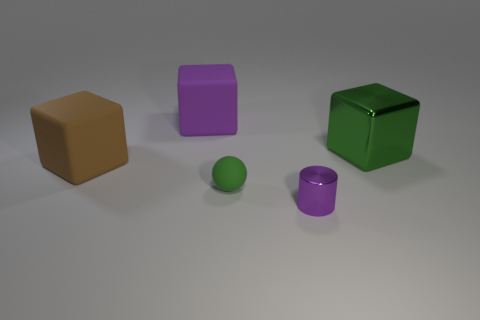What is the shape of the purple thing in front of the green sphere?
Offer a terse response. Cylinder. How many metal objects have the same size as the matte ball?
Your response must be concise. 1. How big is the green cube?
Offer a terse response. Large. How many big purple rubber things are behind the tiny green matte thing?
Keep it short and to the point. 1. There is another object that is the same material as the tiny purple thing; what shape is it?
Offer a very short reply. Cube. Are there fewer shiny cylinders in front of the large green metal thing than big objects that are left of the small green matte sphere?
Provide a succinct answer. Yes. Is the number of big brown rubber objects greater than the number of yellow cylinders?
Keep it short and to the point. Yes. What is the material of the purple block?
Keep it short and to the point. Rubber. There is a block right of the tiny green ball; what is its color?
Make the answer very short. Green. Is the number of green objects that are behind the tiny green object greater than the number of tiny matte objects right of the tiny purple object?
Make the answer very short. Yes. 